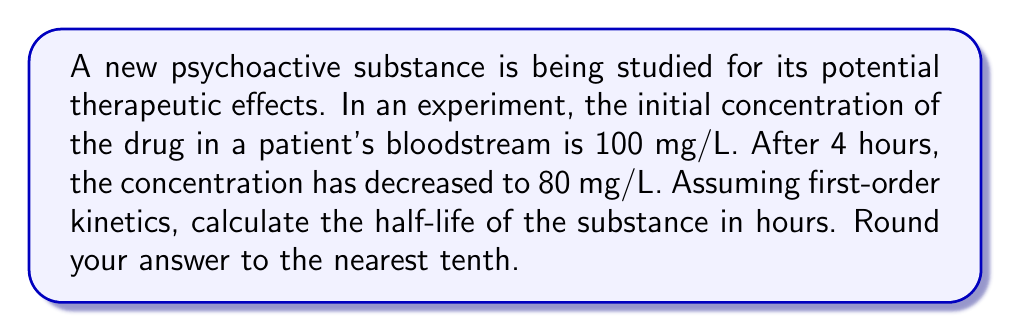Provide a solution to this math problem. Let's approach this step-by-step using the first-order decay equation:

1) The first-order decay equation is:
   $$C_t = C_0 \cdot e^{-kt}$$
   Where:
   $C_t$ is the concentration at time $t$
   $C_0$ is the initial concentration
   $k$ is the decay constant
   $t$ is time

2) We know:
   $C_0 = 100$ mg/L
   $C_t = 80$ mg/L
   $t = 4$ hours

3) Substituting these values:
   $$80 = 100 \cdot e^{-4k}$$

4) Dividing both sides by 100:
   $$0.8 = e^{-4k}$$

5) Taking the natural log of both sides:
   $$\ln(0.8) = -4k$$

6) Solving for $k$:
   $$k = -\frac{\ln(0.8)}{4} \approx 0.0558$$

7) The half-life ($t_{1/2}$) is related to $k$ by:
   $$t_{1/2} = \frac{\ln(2)}{k}$$

8) Substituting our value for $k$:
   $$t_{1/2} = \frac{\ln(2)}{0.0558} \approx 12.4$$ hours

9) Rounding to the nearest tenth:
   $t_{1/2} \approx 12.4$ hours
Answer: 12.4 hours 